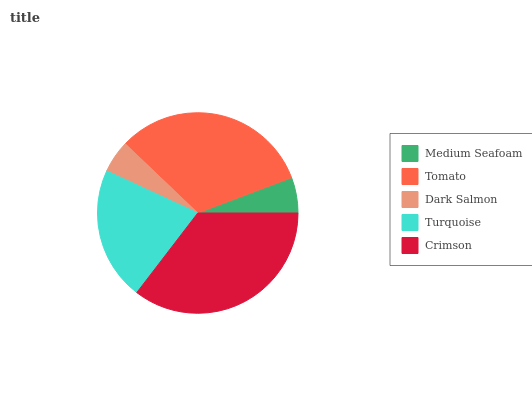Is Dark Salmon the minimum?
Answer yes or no. Yes. Is Crimson the maximum?
Answer yes or no. Yes. Is Tomato the minimum?
Answer yes or no. No. Is Tomato the maximum?
Answer yes or no. No. Is Tomato greater than Medium Seafoam?
Answer yes or no. Yes. Is Medium Seafoam less than Tomato?
Answer yes or no. Yes. Is Medium Seafoam greater than Tomato?
Answer yes or no. No. Is Tomato less than Medium Seafoam?
Answer yes or no. No. Is Turquoise the high median?
Answer yes or no. Yes. Is Turquoise the low median?
Answer yes or no. Yes. Is Crimson the high median?
Answer yes or no. No. Is Tomato the low median?
Answer yes or no. No. 